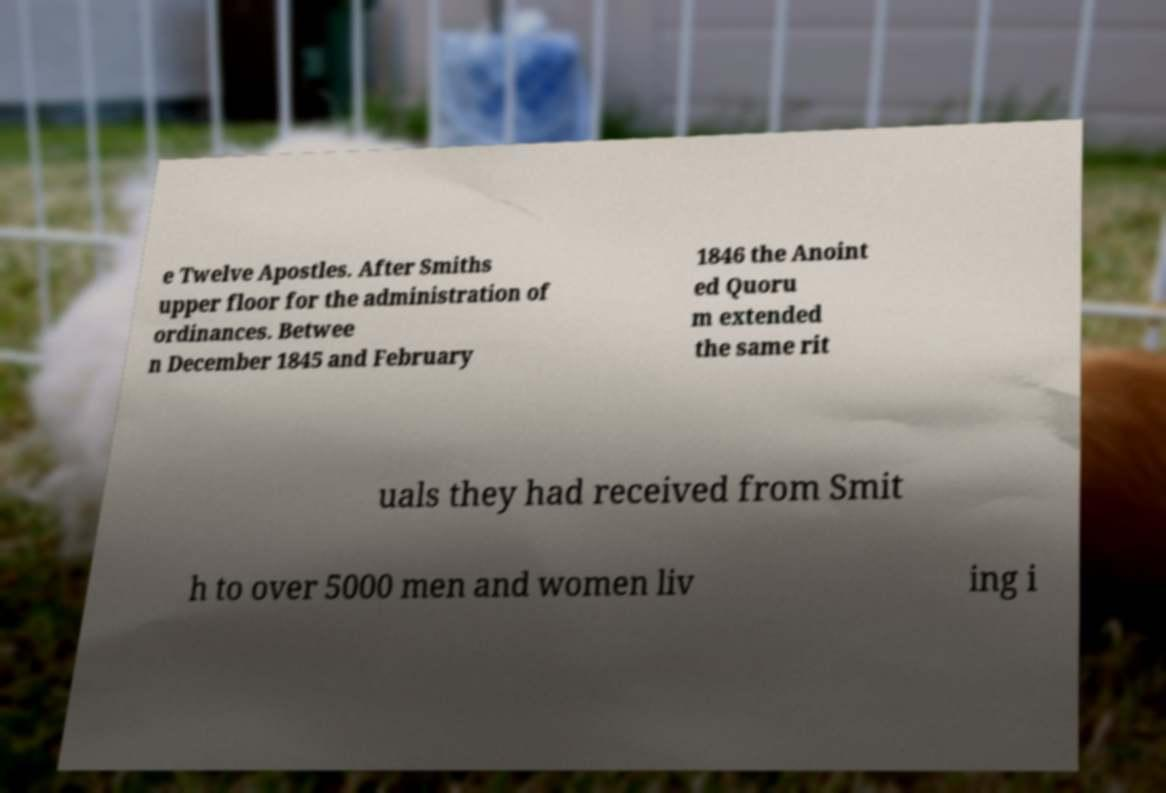What messages or text are displayed in this image? I need them in a readable, typed format. e Twelve Apostles. After Smiths upper floor for the administration of ordinances. Betwee n December 1845 and February 1846 the Anoint ed Quoru m extended the same rit uals they had received from Smit h to over 5000 men and women liv ing i 